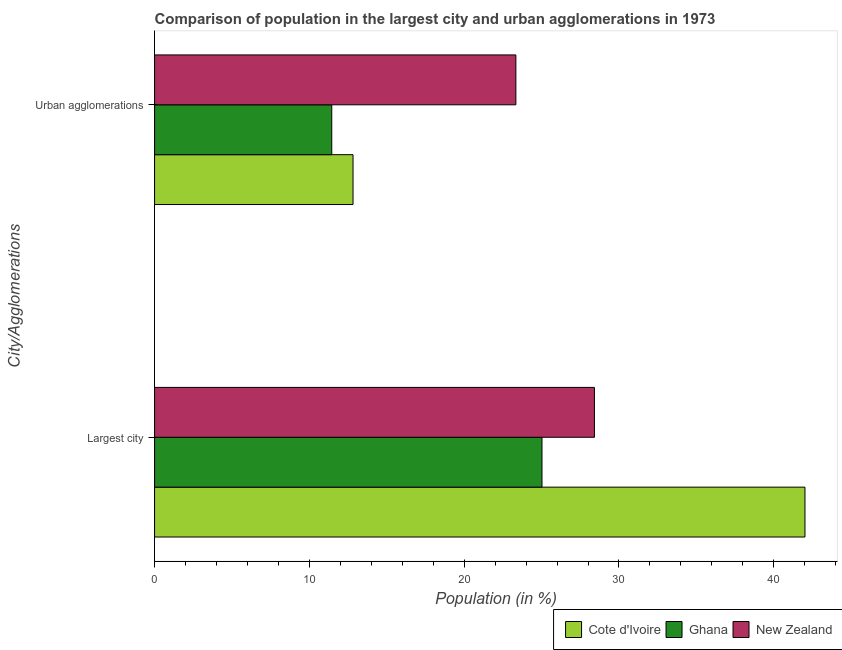How many different coloured bars are there?
Offer a terse response. 3. How many groups of bars are there?
Offer a very short reply. 2. Are the number of bars per tick equal to the number of legend labels?
Provide a short and direct response. Yes. How many bars are there on the 1st tick from the top?
Your answer should be very brief. 3. What is the label of the 2nd group of bars from the top?
Your answer should be compact. Largest city. What is the population in urban agglomerations in Ghana?
Keep it short and to the point. 11.45. Across all countries, what is the maximum population in the largest city?
Provide a succinct answer. 42.02. Across all countries, what is the minimum population in urban agglomerations?
Your response must be concise. 11.45. In which country was the population in urban agglomerations maximum?
Give a very brief answer. New Zealand. What is the total population in urban agglomerations in the graph?
Ensure brevity in your answer.  47.61. What is the difference between the population in the largest city in New Zealand and that in Cote d'Ivoire?
Ensure brevity in your answer.  -13.6. What is the difference between the population in the largest city in Ghana and the population in urban agglomerations in Cote d'Ivoire?
Make the answer very short. 12.21. What is the average population in the largest city per country?
Provide a short and direct response. 31.82. What is the difference between the population in urban agglomerations and population in the largest city in New Zealand?
Your response must be concise. -5.07. What is the ratio of the population in urban agglomerations in New Zealand to that in Ghana?
Offer a very short reply. 2.04. Is the population in the largest city in Ghana less than that in New Zealand?
Give a very brief answer. Yes. In how many countries, is the population in urban agglomerations greater than the average population in urban agglomerations taken over all countries?
Provide a short and direct response. 1. What does the 1st bar from the bottom in Largest city represents?
Provide a short and direct response. Cote d'Ivoire. How many legend labels are there?
Keep it short and to the point. 3. What is the title of the graph?
Provide a short and direct response. Comparison of population in the largest city and urban agglomerations in 1973. What is the label or title of the X-axis?
Provide a succinct answer. Population (in %). What is the label or title of the Y-axis?
Provide a succinct answer. City/Agglomerations. What is the Population (in %) in Cote d'Ivoire in Largest city?
Give a very brief answer. 42.02. What is the Population (in %) in Ghana in Largest city?
Provide a short and direct response. 25.03. What is the Population (in %) of New Zealand in Largest city?
Provide a short and direct response. 28.42. What is the Population (in %) in Cote d'Ivoire in Urban agglomerations?
Ensure brevity in your answer.  12.82. What is the Population (in %) of Ghana in Urban agglomerations?
Keep it short and to the point. 11.45. What is the Population (in %) in New Zealand in Urban agglomerations?
Your answer should be very brief. 23.34. Across all City/Agglomerations, what is the maximum Population (in %) of Cote d'Ivoire?
Offer a very short reply. 42.02. Across all City/Agglomerations, what is the maximum Population (in %) of Ghana?
Provide a succinct answer. 25.03. Across all City/Agglomerations, what is the maximum Population (in %) of New Zealand?
Give a very brief answer. 28.42. Across all City/Agglomerations, what is the minimum Population (in %) in Cote d'Ivoire?
Your answer should be very brief. 12.82. Across all City/Agglomerations, what is the minimum Population (in %) in Ghana?
Give a very brief answer. 11.45. Across all City/Agglomerations, what is the minimum Population (in %) in New Zealand?
Make the answer very short. 23.34. What is the total Population (in %) of Cote d'Ivoire in the graph?
Give a very brief answer. 54.84. What is the total Population (in %) in Ghana in the graph?
Keep it short and to the point. 36.47. What is the total Population (in %) in New Zealand in the graph?
Provide a succinct answer. 51.76. What is the difference between the Population (in %) of Cote d'Ivoire in Largest city and that in Urban agglomerations?
Your answer should be very brief. 29.2. What is the difference between the Population (in %) in Ghana in Largest city and that in Urban agglomerations?
Offer a terse response. 13.58. What is the difference between the Population (in %) of New Zealand in Largest city and that in Urban agglomerations?
Your answer should be very brief. 5.07. What is the difference between the Population (in %) in Cote d'Ivoire in Largest city and the Population (in %) in Ghana in Urban agglomerations?
Provide a succinct answer. 30.57. What is the difference between the Population (in %) in Cote d'Ivoire in Largest city and the Population (in %) in New Zealand in Urban agglomerations?
Your answer should be very brief. 18.68. What is the difference between the Population (in %) of Ghana in Largest city and the Population (in %) of New Zealand in Urban agglomerations?
Keep it short and to the point. 1.69. What is the average Population (in %) in Cote d'Ivoire per City/Agglomerations?
Ensure brevity in your answer.  27.42. What is the average Population (in %) of Ghana per City/Agglomerations?
Your answer should be compact. 18.24. What is the average Population (in %) in New Zealand per City/Agglomerations?
Offer a very short reply. 25.88. What is the difference between the Population (in %) in Cote d'Ivoire and Population (in %) in Ghana in Largest city?
Your answer should be compact. 16.99. What is the difference between the Population (in %) in Cote d'Ivoire and Population (in %) in New Zealand in Largest city?
Provide a short and direct response. 13.6. What is the difference between the Population (in %) in Ghana and Population (in %) in New Zealand in Largest city?
Your response must be concise. -3.39. What is the difference between the Population (in %) in Cote d'Ivoire and Population (in %) in Ghana in Urban agglomerations?
Keep it short and to the point. 1.37. What is the difference between the Population (in %) of Cote d'Ivoire and Population (in %) of New Zealand in Urban agglomerations?
Make the answer very short. -10.52. What is the difference between the Population (in %) in Ghana and Population (in %) in New Zealand in Urban agglomerations?
Your answer should be compact. -11.9. What is the ratio of the Population (in %) of Cote d'Ivoire in Largest city to that in Urban agglomerations?
Make the answer very short. 3.28. What is the ratio of the Population (in %) in Ghana in Largest city to that in Urban agglomerations?
Your answer should be compact. 2.19. What is the ratio of the Population (in %) in New Zealand in Largest city to that in Urban agglomerations?
Your response must be concise. 1.22. What is the difference between the highest and the second highest Population (in %) of Cote d'Ivoire?
Provide a short and direct response. 29.2. What is the difference between the highest and the second highest Population (in %) of Ghana?
Keep it short and to the point. 13.58. What is the difference between the highest and the second highest Population (in %) in New Zealand?
Keep it short and to the point. 5.07. What is the difference between the highest and the lowest Population (in %) in Cote d'Ivoire?
Your answer should be very brief. 29.2. What is the difference between the highest and the lowest Population (in %) in Ghana?
Your answer should be very brief. 13.58. What is the difference between the highest and the lowest Population (in %) of New Zealand?
Offer a terse response. 5.07. 